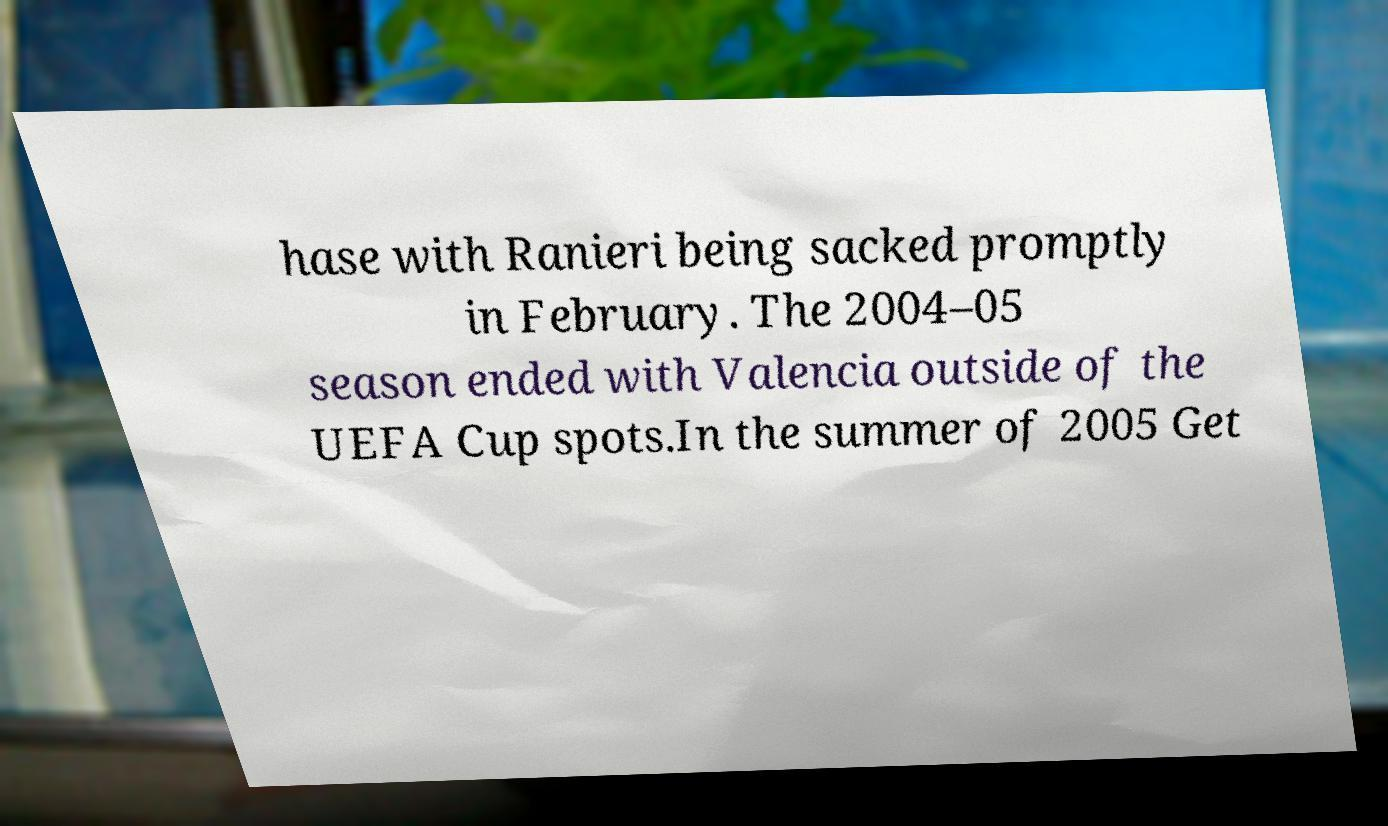There's text embedded in this image that I need extracted. Can you transcribe it verbatim? hase with Ranieri being sacked promptly in February. The 2004–05 season ended with Valencia outside of the UEFA Cup spots.In the summer of 2005 Get 